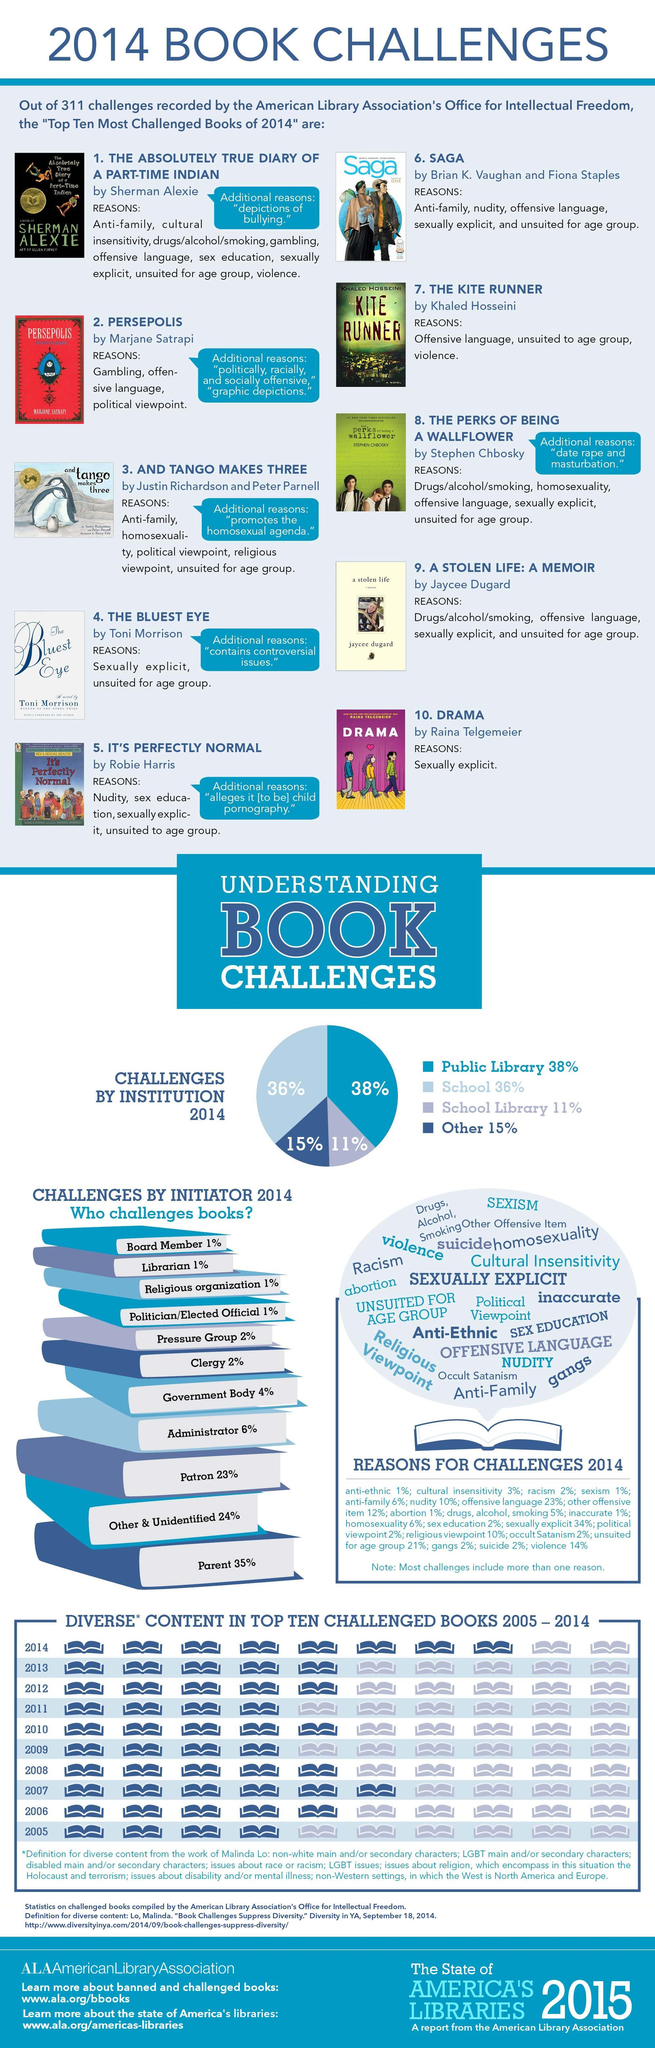What percentage of challenges by Clergy and Patron, taken together?
Answer the question with a short phrase. 25% How many initiators challenges the book? 11 What percentage of challenges by public library and school, taken together? 74% How many diverse contents in the 2014 challenged book? 8 What percentage of violence and suicide together are the reasons for challenges? 16% What percentage of challenges by school library and others, taken together? 26% What percentage of challenges by Board member and Librarian, taken together? 2% How many diverse contents in the 2013 challenged book? 5 What percentage of sexism and racism together are the reasons for challenges? 3% What percentage of challenges by Parent and Religious organization, taken together? 36% 